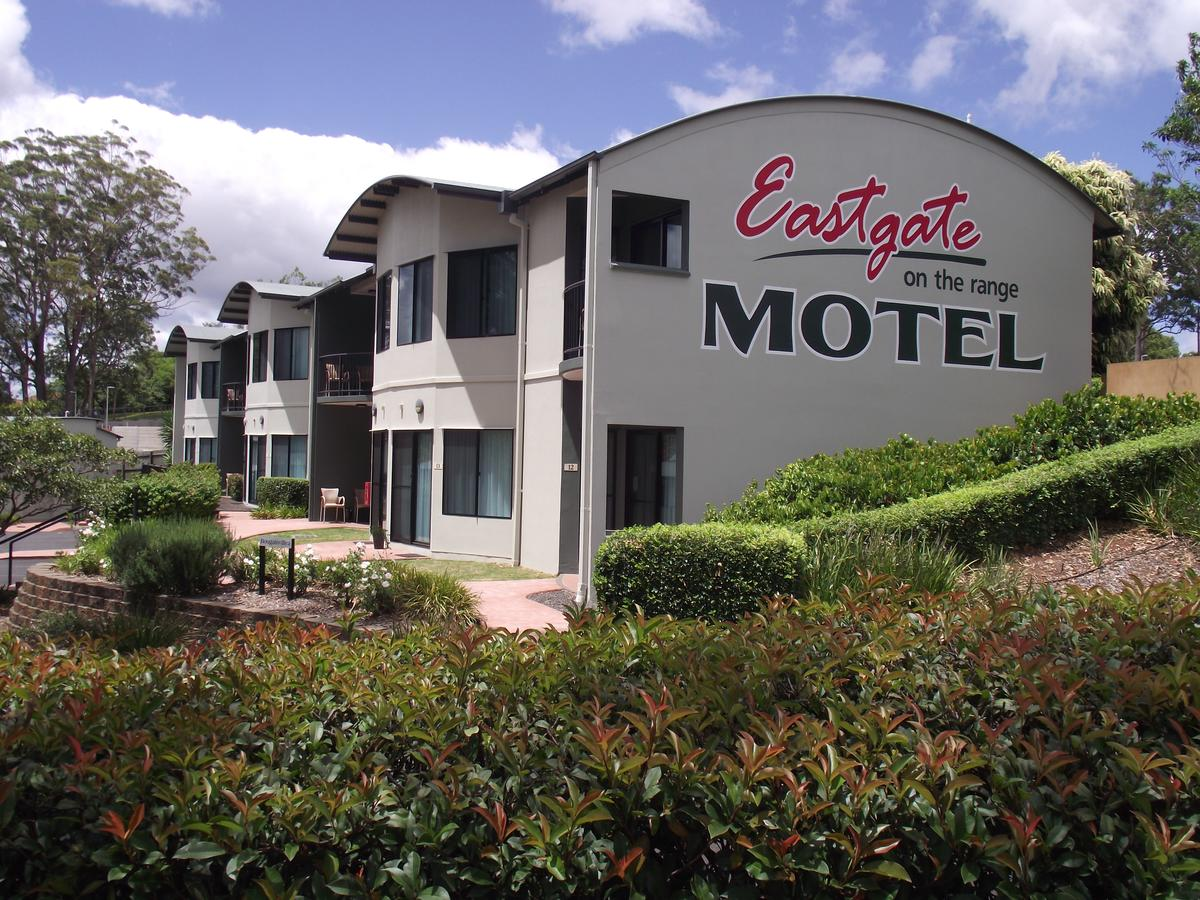Reflecting on the signage, what can be inferred about the branding strategy of the motel? The large, prominent signage using bold, contrasting colors of red and gray and a mix of script and block fonts, implies a branding strategy aimed at capturing attention and conveying a sense of robustness and hospitality. This suggests that the motel prioritizes visibility and wants to project an image of comfort and reliability to passing travelers. 